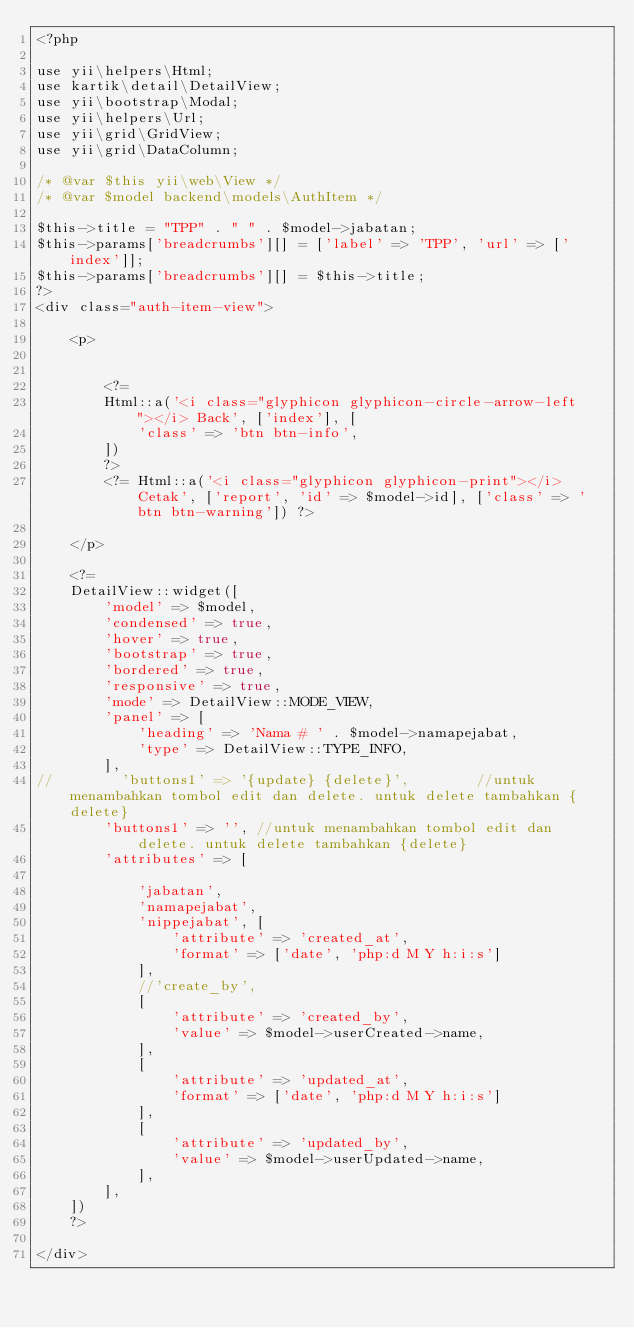Convert code to text. <code><loc_0><loc_0><loc_500><loc_500><_PHP_><?php

use yii\helpers\Html;
use kartik\detail\DetailView;
use yii\bootstrap\Modal;
use yii\helpers\Url;
use yii\grid\GridView;
use yii\grid\DataColumn;

/* @var $this yii\web\View */
/* @var $model backend\models\AuthItem */

$this->title = "TPP" . " " . $model->jabatan;
$this->params['breadcrumbs'][] = ['label' => 'TPP', 'url' => ['index']];
$this->params['breadcrumbs'][] = $this->title;
?>
<div class="auth-item-view">

    <p>


        <?=
        Html::a('<i class="glyphicon glyphicon-circle-arrow-left"></i> Back', ['index'], [
            'class' => 'btn btn-info',
        ])
        ?>
        <?= Html::a('<i class="glyphicon glyphicon-print"></i> Cetak', ['report', 'id' => $model->id], ['class' => 'btn btn-warning']) ?>

    </p>

    <?=
    DetailView::widget([
        'model' => $model,
        'condensed' => true,
        'hover' => true,
        'bootstrap' => true,
        'bordered' => true,
        'responsive' => true,
        'mode' => DetailView::MODE_VIEW,
        'panel' => [
            'heading' => 'Nama # ' . $model->namapejabat,
            'type' => DetailView::TYPE_INFO,
        ],
//        'buttons1' => '{update} {delete}',        //untuk menambahkan tombol edit dan delete. untuk delete tambahkan {delete}
        'buttons1' => '', //untuk menambahkan tombol edit dan delete. untuk delete tambahkan {delete}
        'attributes' => [

            'jabatan',
            'namapejabat',
            'nippejabat', [
                'attribute' => 'created_at',
                'format' => ['date', 'php:d M Y h:i:s']
            ],
            //'create_by',
            [
                'attribute' => 'created_by',
                'value' => $model->userCreated->name,
            ],
            [
                'attribute' => 'updated_at',
                'format' => ['date', 'php:d M Y h:i:s']
            ],
            [
                'attribute' => 'updated_by',
                'value' => $model->userUpdated->name,
            ],
        ],
    ])
    ?>

</div>


</code> 